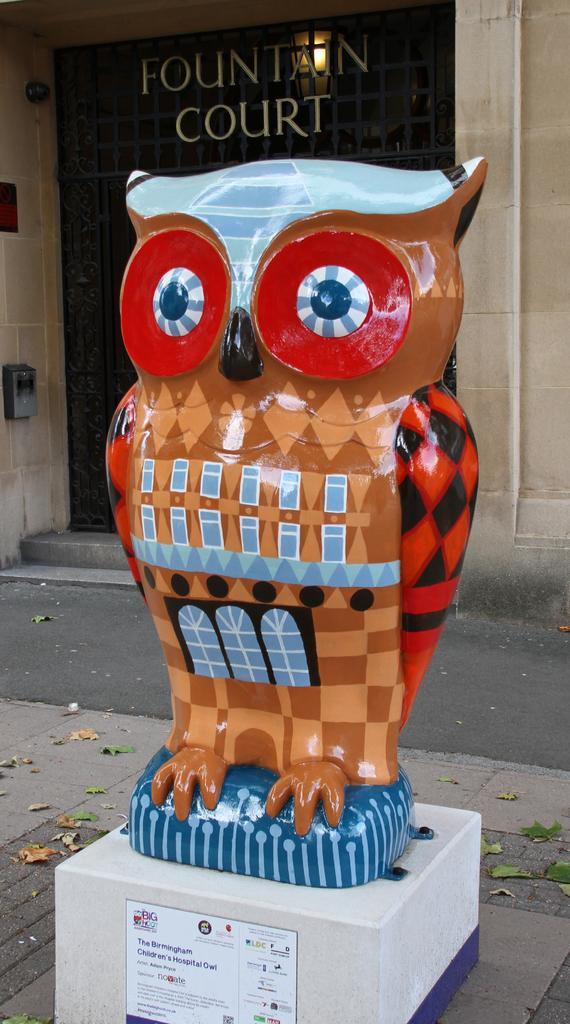In one or two sentences, can you explain what this image depicts? In the image there is a statue of an owl and behind the statue there is a building. 